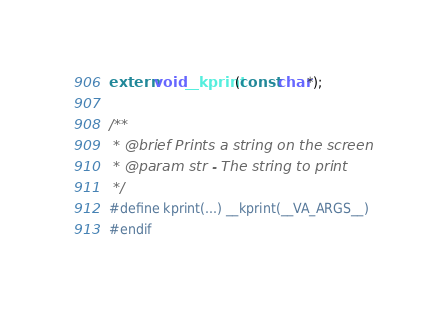Convert code to text. <code><loc_0><loc_0><loc_500><loc_500><_C_>extern void __kprint(const char*);

/**
 * @brief Prints a string on the screen
 * @param str - The string to print
 */
#define kprint(...) __kprint(__VA_ARGS__)
#endif
</code> 